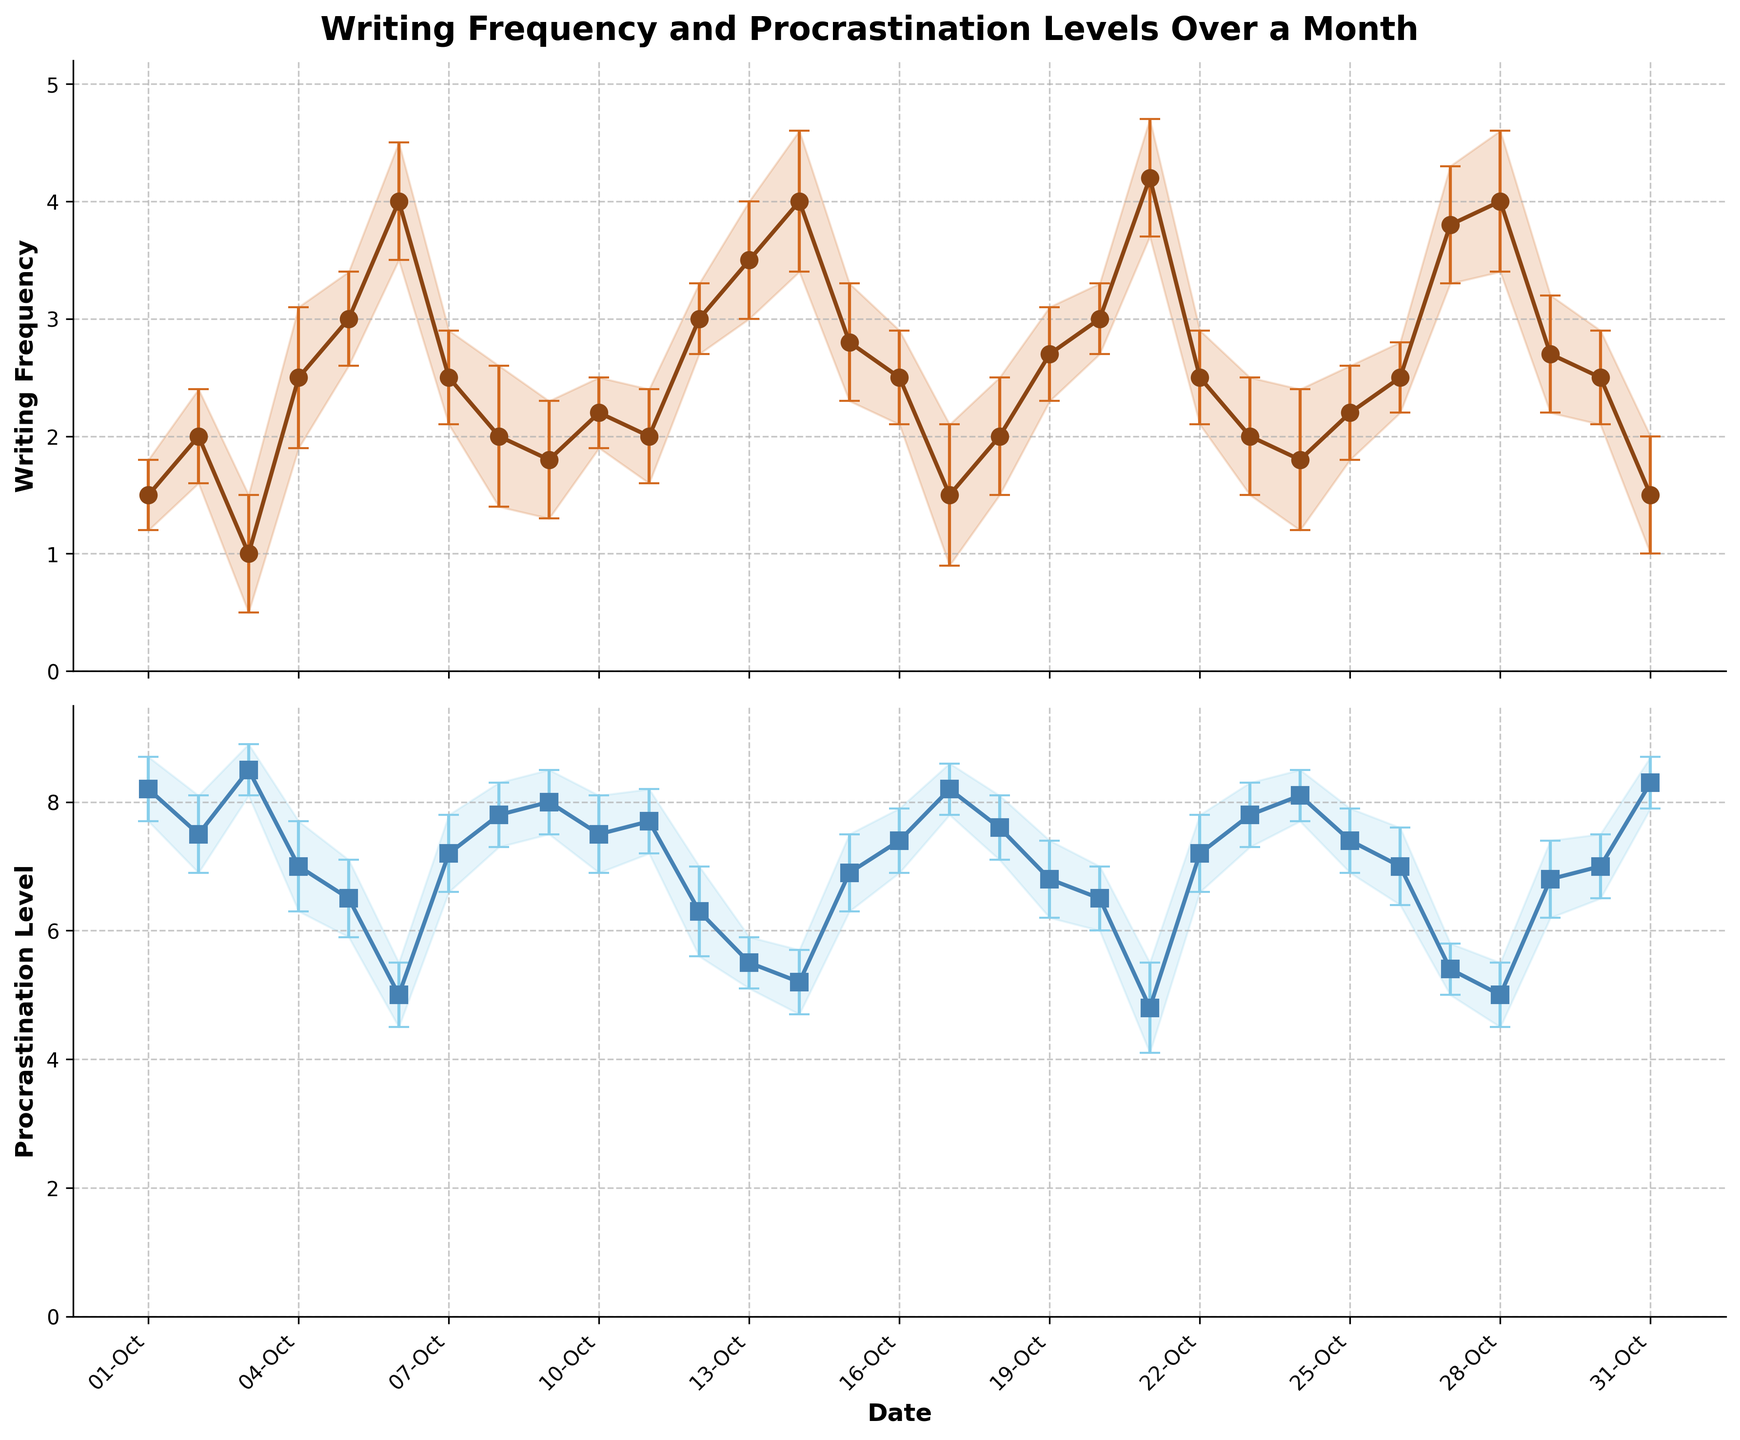what's the title of the figure? The title is displayed at the top of the figure, above the subplots.
Answer: Writing Frequency and Procrastination Levels Over a Month how many data points are there in the plot? By examining the x-axis, we see that there is one point plotted for each day in October, totaling 31 points.
Answer: 31 how does the writing frequency on October 13 compare to the procrastination level on the same date? Locate October 13 on the x-axis in both subplots. Writing frequency on this date is about 3.5, whereas the procrastination level is around 5.5.
Answer: Writing frequency is higher which date shows the maximum procrastination level? By comparing the peaks in the procrastination level subplot, we find that October 31 has the highest procrastination level.
Answer: October 31 for which date is the error bar the longest in the writing frequency subplot? The length of the error bar is visible in the figure as the vertical line with caps. October 4 has the longest error bar in the writing frequency subplot.
Answer: October 4 what's the range of procrastination levels throughout the month? The range is determined by subtracting the minimum value from the maximum value in the procrastination level subplot. The highest level is around 8.5 (Oct 3 and Oct 31), and the lowest is about 4.8 (Oct 21). Hence, the range is 8.5 - 4.8.
Answer: 3.7 how do the trends of writing frequency and procrastination level compare over the month? Look at the general direction of the lines in both subplots. Writing frequency generally trends upwards, peaking mid-month and tailing off at the end, while procrastination levels trend downwards over the same period.
Answer: Writing frequency up, procrastination level down which date shows the minimum writing frequency and what is the approximate value? Locate the lowest point in the writing frequency subplot. The lowest writing frequency is on October 3 with a value around 1.0.
Answer: October 3, 1.0 does any date have equal writing frequency and procrastination level? Visually inspect both subplots to see if the writing frequency and procrastination level lines intersect or have the same y-value at any x-value. It doesn't appear that any date has equal values for both metrics.
Answer: No what is the average writing frequency over the last seven days of the month? Sum of writing frequencies from Oct 25 to Oct 31: 2.2 + 2.5 + 3.8 + 4.0 + 2.7 + 2.5 + 1.5 = 19.2. Then, divide by 7: 19.2 / 7 = 2.74.
Answer: 2.74 